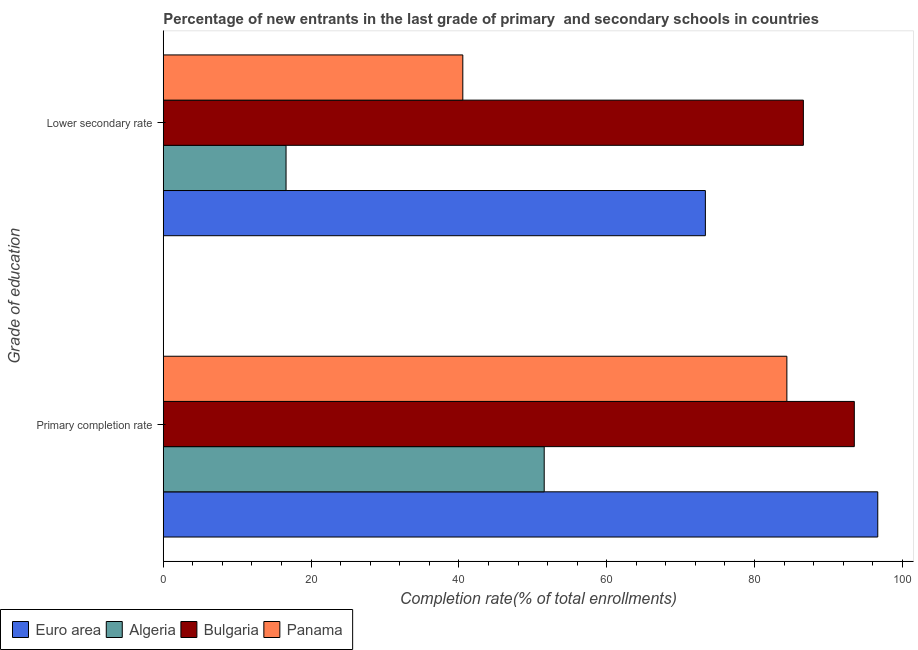How many bars are there on the 1st tick from the top?
Offer a very short reply. 4. What is the label of the 2nd group of bars from the top?
Provide a succinct answer. Primary completion rate. What is the completion rate in secondary schools in Panama?
Your response must be concise. 40.53. Across all countries, what is the maximum completion rate in secondary schools?
Provide a short and direct response. 86.61. Across all countries, what is the minimum completion rate in secondary schools?
Your answer should be compact. 16.61. In which country was the completion rate in primary schools minimum?
Give a very brief answer. Algeria. What is the total completion rate in primary schools in the graph?
Your answer should be compact. 326.08. What is the difference between the completion rate in secondary schools in Panama and that in Algeria?
Keep it short and to the point. 23.91. What is the difference between the completion rate in secondary schools in Bulgaria and the completion rate in primary schools in Panama?
Ensure brevity in your answer.  2.23. What is the average completion rate in secondary schools per country?
Give a very brief answer. 54.27. What is the difference between the completion rate in primary schools and completion rate in secondary schools in Panama?
Provide a succinct answer. 43.85. What is the ratio of the completion rate in secondary schools in Bulgaria to that in Algeria?
Make the answer very short. 5.21. Is the completion rate in secondary schools in Euro area less than that in Bulgaria?
Give a very brief answer. Yes. In how many countries, is the completion rate in primary schools greater than the average completion rate in primary schools taken over all countries?
Offer a terse response. 3. What does the 3rd bar from the top in Lower secondary rate represents?
Ensure brevity in your answer.  Algeria. What does the 3rd bar from the bottom in Primary completion rate represents?
Give a very brief answer. Bulgaria. How many bars are there?
Make the answer very short. 8. How many countries are there in the graph?
Offer a very short reply. 4. What is the difference between two consecutive major ticks on the X-axis?
Give a very brief answer. 20. Where does the legend appear in the graph?
Offer a terse response. Bottom left. What is the title of the graph?
Offer a very short reply. Percentage of new entrants in the last grade of primary  and secondary schools in countries. What is the label or title of the X-axis?
Provide a succinct answer. Completion rate(% of total enrollments). What is the label or title of the Y-axis?
Your answer should be very brief. Grade of education. What is the Completion rate(% of total enrollments) in Euro area in Primary completion rate?
Your answer should be compact. 96.67. What is the Completion rate(% of total enrollments) of Algeria in Primary completion rate?
Your response must be concise. 51.54. What is the Completion rate(% of total enrollments) of Bulgaria in Primary completion rate?
Offer a very short reply. 93.5. What is the Completion rate(% of total enrollments) in Panama in Primary completion rate?
Your answer should be compact. 84.37. What is the Completion rate(% of total enrollments) in Euro area in Lower secondary rate?
Keep it short and to the point. 73.34. What is the Completion rate(% of total enrollments) in Algeria in Lower secondary rate?
Ensure brevity in your answer.  16.61. What is the Completion rate(% of total enrollments) in Bulgaria in Lower secondary rate?
Keep it short and to the point. 86.61. What is the Completion rate(% of total enrollments) of Panama in Lower secondary rate?
Offer a very short reply. 40.53. Across all Grade of education, what is the maximum Completion rate(% of total enrollments) of Euro area?
Provide a succinct answer. 96.67. Across all Grade of education, what is the maximum Completion rate(% of total enrollments) in Algeria?
Provide a short and direct response. 51.54. Across all Grade of education, what is the maximum Completion rate(% of total enrollments) in Bulgaria?
Offer a very short reply. 93.5. Across all Grade of education, what is the maximum Completion rate(% of total enrollments) of Panama?
Your answer should be very brief. 84.37. Across all Grade of education, what is the minimum Completion rate(% of total enrollments) in Euro area?
Provide a short and direct response. 73.34. Across all Grade of education, what is the minimum Completion rate(% of total enrollments) in Algeria?
Keep it short and to the point. 16.61. Across all Grade of education, what is the minimum Completion rate(% of total enrollments) of Bulgaria?
Provide a short and direct response. 86.61. Across all Grade of education, what is the minimum Completion rate(% of total enrollments) of Panama?
Give a very brief answer. 40.53. What is the total Completion rate(% of total enrollments) in Euro area in the graph?
Provide a succinct answer. 170.02. What is the total Completion rate(% of total enrollments) of Algeria in the graph?
Provide a succinct answer. 68.15. What is the total Completion rate(% of total enrollments) of Bulgaria in the graph?
Provide a succinct answer. 180.1. What is the total Completion rate(% of total enrollments) of Panama in the graph?
Your answer should be compact. 124.9. What is the difference between the Completion rate(% of total enrollments) in Euro area in Primary completion rate and that in Lower secondary rate?
Keep it short and to the point. 23.33. What is the difference between the Completion rate(% of total enrollments) in Algeria in Primary completion rate and that in Lower secondary rate?
Provide a succinct answer. 34.93. What is the difference between the Completion rate(% of total enrollments) in Bulgaria in Primary completion rate and that in Lower secondary rate?
Offer a very short reply. 6.89. What is the difference between the Completion rate(% of total enrollments) of Panama in Primary completion rate and that in Lower secondary rate?
Your response must be concise. 43.85. What is the difference between the Completion rate(% of total enrollments) of Euro area in Primary completion rate and the Completion rate(% of total enrollments) of Algeria in Lower secondary rate?
Offer a terse response. 80.06. What is the difference between the Completion rate(% of total enrollments) in Euro area in Primary completion rate and the Completion rate(% of total enrollments) in Bulgaria in Lower secondary rate?
Your response must be concise. 10.06. What is the difference between the Completion rate(% of total enrollments) of Euro area in Primary completion rate and the Completion rate(% of total enrollments) of Panama in Lower secondary rate?
Give a very brief answer. 56.14. What is the difference between the Completion rate(% of total enrollments) in Algeria in Primary completion rate and the Completion rate(% of total enrollments) in Bulgaria in Lower secondary rate?
Ensure brevity in your answer.  -35.07. What is the difference between the Completion rate(% of total enrollments) of Algeria in Primary completion rate and the Completion rate(% of total enrollments) of Panama in Lower secondary rate?
Offer a very short reply. 11.01. What is the difference between the Completion rate(% of total enrollments) of Bulgaria in Primary completion rate and the Completion rate(% of total enrollments) of Panama in Lower secondary rate?
Offer a very short reply. 52.97. What is the average Completion rate(% of total enrollments) in Euro area per Grade of education?
Keep it short and to the point. 85.01. What is the average Completion rate(% of total enrollments) of Algeria per Grade of education?
Offer a very short reply. 34.08. What is the average Completion rate(% of total enrollments) in Bulgaria per Grade of education?
Provide a succinct answer. 90.05. What is the average Completion rate(% of total enrollments) of Panama per Grade of education?
Ensure brevity in your answer.  62.45. What is the difference between the Completion rate(% of total enrollments) in Euro area and Completion rate(% of total enrollments) in Algeria in Primary completion rate?
Your response must be concise. 45.13. What is the difference between the Completion rate(% of total enrollments) in Euro area and Completion rate(% of total enrollments) in Bulgaria in Primary completion rate?
Give a very brief answer. 3.17. What is the difference between the Completion rate(% of total enrollments) of Euro area and Completion rate(% of total enrollments) of Panama in Primary completion rate?
Your response must be concise. 12.3. What is the difference between the Completion rate(% of total enrollments) in Algeria and Completion rate(% of total enrollments) in Bulgaria in Primary completion rate?
Provide a short and direct response. -41.96. What is the difference between the Completion rate(% of total enrollments) in Algeria and Completion rate(% of total enrollments) in Panama in Primary completion rate?
Provide a succinct answer. -32.83. What is the difference between the Completion rate(% of total enrollments) in Bulgaria and Completion rate(% of total enrollments) in Panama in Primary completion rate?
Provide a succinct answer. 9.12. What is the difference between the Completion rate(% of total enrollments) of Euro area and Completion rate(% of total enrollments) of Algeria in Lower secondary rate?
Provide a succinct answer. 56.73. What is the difference between the Completion rate(% of total enrollments) in Euro area and Completion rate(% of total enrollments) in Bulgaria in Lower secondary rate?
Offer a terse response. -13.26. What is the difference between the Completion rate(% of total enrollments) of Euro area and Completion rate(% of total enrollments) of Panama in Lower secondary rate?
Make the answer very short. 32.82. What is the difference between the Completion rate(% of total enrollments) of Algeria and Completion rate(% of total enrollments) of Bulgaria in Lower secondary rate?
Make the answer very short. -69.99. What is the difference between the Completion rate(% of total enrollments) of Algeria and Completion rate(% of total enrollments) of Panama in Lower secondary rate?
Keep it short and to the point. -23.91. What is the difference between the Completion rate(% of total enrollments) of Bulgaria and Completion rate(% of total enrollments) of Panama in Lower secondary rate?
Provide a succinct answer. 46.08. What is the ratio of the Completion rate(% of total enrollments) in Euro area in Primary completion rate to that in Lower secondary rate?
Provide a succinct answer. 1.32. What is the ratio of the Completion rate(% of total enrollments) of Algeria in Primary completion rate to that in Lower secondary rate?
Provide a short and direct response. 3.1. What is the ratio of the Completion rate(% of total enrollments) in Bulgaria in Primary completion rate to that in Lower secondary rate?
Provide a short and direct response. 1.08. What is the ratio of the Completion rate(% of total enrollments) of Panama in Primary completion rate to that in Lower secondary rate?
Your answer should be compact. 2.08. What is the difference between the highest and the second highest Completion rate(% of total enrollments) of Euro area?
Keep it short and to the point. 23.33. What is the difference between the highest and the second highest Completion rate(% of total enrollments) of Algeria?
Provide a succinct answer. 34.93. What is the difference between the highest and the second highest Completion rate(% of total enrollments) in Bulgaria?
Make the answer very short. 6.89. What is the difference between the highest and the second highest Completion rate(% of total enrollments) in Panama?
Ensure brevity in your answer.  43.85. What is the difference between the highest and the lowest Completion rate(% of total enrollments) of Euro area?
Offer a very short reply. 23.33. What is the difference between the highest and the lowest Completion rate(% of total enrollments) in Algeria?
Provide a short and direct response. 34.93. What is the difference between the highest and the lowest Completion rate(% of total enrollments) in Bulgaria?
Give a very brief answer. 6.89. What is the difference between the highest and the lowest Completion rate(% of total enrollments) in Panama?
Your answer should be very brief. 43.85. 